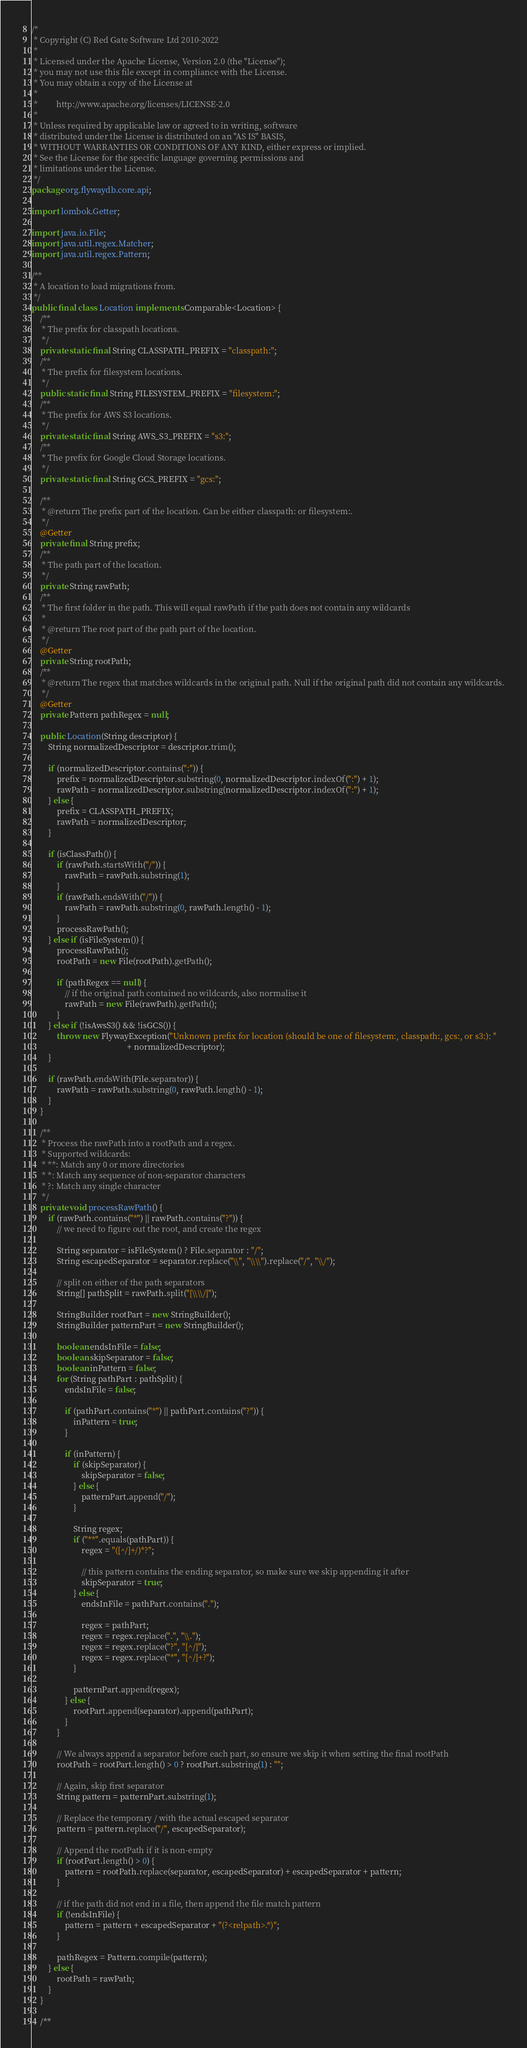Convert code to text. <code><loc_0><loc_0><loc_500><loc_500><_Java_>/*
 * Copyright (C) Red Gate Software Ltd 2010-2022
 *
 * Licensed under the Apache License, Version 2.0 (the "License");
 * you may not use this file except in compliance with the License.
 * You may obtain a copy of the License at
 *
 *         http://www.apache.org/licenses/LICENSE-2.0
 *
 * Unless required by applicable law or agreed to in writing, software
 * distributed under the License is distributed on an "AS IS" BASIS,
 * WITHOUT WARRANTIES OR CONDITIONS OF ANY KIND, either express or implied.
 * See the License for the specific language governing permissions and
 * limitations under the License.
 */
package org.flywaydb.core.api;

import lombok.Getter;

import java.io.File;
import java.util.regex.Matcher;
import java.util.regex.Pattern;

/**
 * A location to load migrations from.
 */
public final class Location implements Comparable<Location> {
    /**
     * The prefix for classpath locations.
     */
    private static final String CLASSPATH_PREFIX = "classpath:";
    /**
     * The prefix for filesystem locations.
     */
    public static final String FILESYSTEM_PREFIX = "filesystem:";
    /**
     * The prefix for AWS S3 locations.
     */
    private static final String AWS_S3_PREFIX = "s3:";
    /**
     * The prefix for Google Cloud Storage locations.
     */
    private static final String GCS_PREFIX = "gcs:";

    /**
     * @return The prefix part of the location. Can be either classpath: or filesystem:.
     */
    @Getter
    private final String prefix;
    /**
     * The path part of the location.
     */
    private String rawPath;
    /**
     * The first folder in the path. This will equal rawPath if the path does not contain any wildcards
     *
     * @return The root part of the path part of the location.
     */
    @Getter
    private String rootPath;
    /**
     * @return The regex that matches wildcards in the original path. Null if the original path did not contain any wildcards.
     */
    @Getter
    private Pattern pathRegex = null;

    public Location(String descriptor) {
        String normalizedDescriptor = descriptor.trim();

        if (normalizedDescriptor.contains(":")) {
            prefix = normalizedDescriptor.substring(0, normalizedDescriptor.indexOf(":") + 1);
            rawPath = normalizedDescriptor.substring(normalizedDescriptor.indexOf(":") + 1);
        } else {
            prefix = CLASSPATH_PREFIX;
            rawPath = normalizedDescriptor;
        }

        if (isClassPath()) {
            if (rawPath.startsWith("/")) {
                rawPath = rawPath.substring(1);
            }
            if (rawPath.endsWith("/")) {
                rawPath = rawPath.substring(0, rawPath.length() - 1);
            }
            processRawPath();
        } else if (isFileSystem()) {
            processRawPath();
            rootPath = new File(rootPath).getPath();

            if (pathRegex == null) {
                // if the original path contained no wildcards, also normalise it
                rawPath = new File(rawPath).getPath();
            }
        } else if (!isAwsS3() && !isGCS()) {
            throw new FlywayException("Unknown prefix for location (should be one of filesystem:, classpath:, gcs:, or s3:): "
                                              + normalizedDescriptor);
        }

        if (rawPath.endsWith(File.separator)) {
            rawPath = rawPath.substring(0, rawPath.length() - 1);
        }
    }

    /**
     * Process the rawPath into a rootPath and a regex.
     * Supported wildcards:
     * **: Match any 0 or more directories
     * *: Match any sequence of non-separator characters
     * ?: Match any single character
     */
    private void processRawPath() {
        if (rawPath.contains("*") || rawPath.contains("?")) {
            // we need to figure out the root, and create the regex

            String separator = isFileSystem() ? File.separator : "/";
            String escapedSeparator = separator.replace("\\", "\\\\").replace("/", "\\/");

            // split on either of the path separators
            String[] pathSplit = rawPath.split("[\\\\/]");

            StringBuilder rootPart = new StringBuilder();
            StringBuilder patternPart = new StringBuilder();

            boolean endsInFile = false;
            boolean skipSeparator = false;
            boolean inPattern = false;
            for (String pathPart : pathSplit) {
                endsInFile = false;

                if (pathPart.contains("*") || pathPart.contains("?")) {
                    inPattern = true;
                }

                if (inPattern) {
                    if (skipSeparator) {
                        skipSeparator = false;
                    } else {
                        patternPart.append("/");
                    }

                    String regex;
                    if ("**".equals(pathPart)) {
                        regex = "([^/]+/)*?";

                        // this pattern contains the ending separator, so make sure we skip appending it after
                        skipSeparator = true;
                    } else {
                        endsInFile = pathPart.contains(".");

                        regex = pathPart;
                        regex = regex.replace(".", "\\.");
                        regex = regex.replace("?", "[^/]");
                        regex = regex.replace("*", "[^/]+?");
                    }

                    patternPart.append(regex);
                } else {
                    rootPart.append(separator).append(pathPart);
                }
            }

            // We always append a separator before each part, so ensure we skip it when setting the final rootPath
            rootPath = rootPart.length() > 0 ? rootPart.substring(1) : "";

            // Again, skip first separator
            String pattern = patternPart.substring(1);

            // Replace the temporary / with the actual escaped separator
            pattern = pattern.replace("/", escapedSeparator);

            // Append the rootPath if it is non-empty
            if (rootPart.length() > 0) {
                pattern = rootPath.replace(separator, escapedSeparator) + escapedSeparator + pattern;
            }

            // if the path did not end in a file, then append the file match pattern
            if (!endsInFile) {
                pattern = pattern + escapedSeparator + "(?<relpath>.*)";
            }

            pathRegex = Pattern.compile(pattern);
        } else {
            rootPath = rawPath;
        }
    }

    /**</code> 